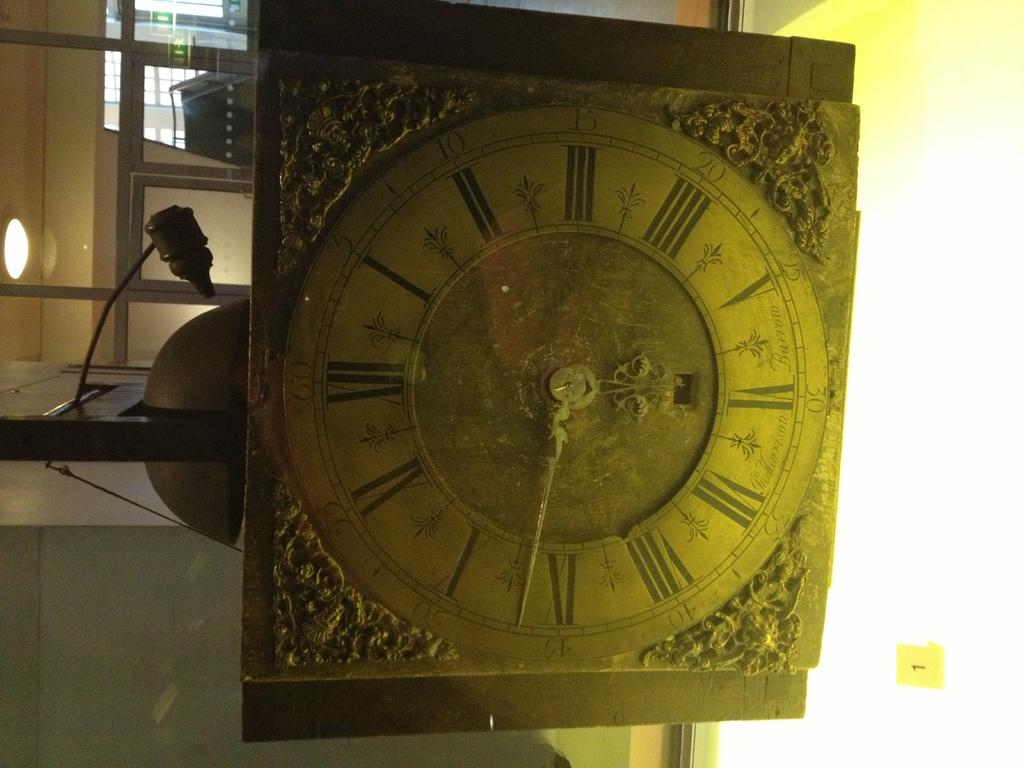What is the main object in the center of the image? There is a clock in the center of the image. What can be seen on the left side of the image? There is a wall on the left side of the image. Where is the mailbox located in the image? There is no mailbox present in the image. What type of town is depicted in the image? The image does not depict a town; it only shows a clock and a wall. 